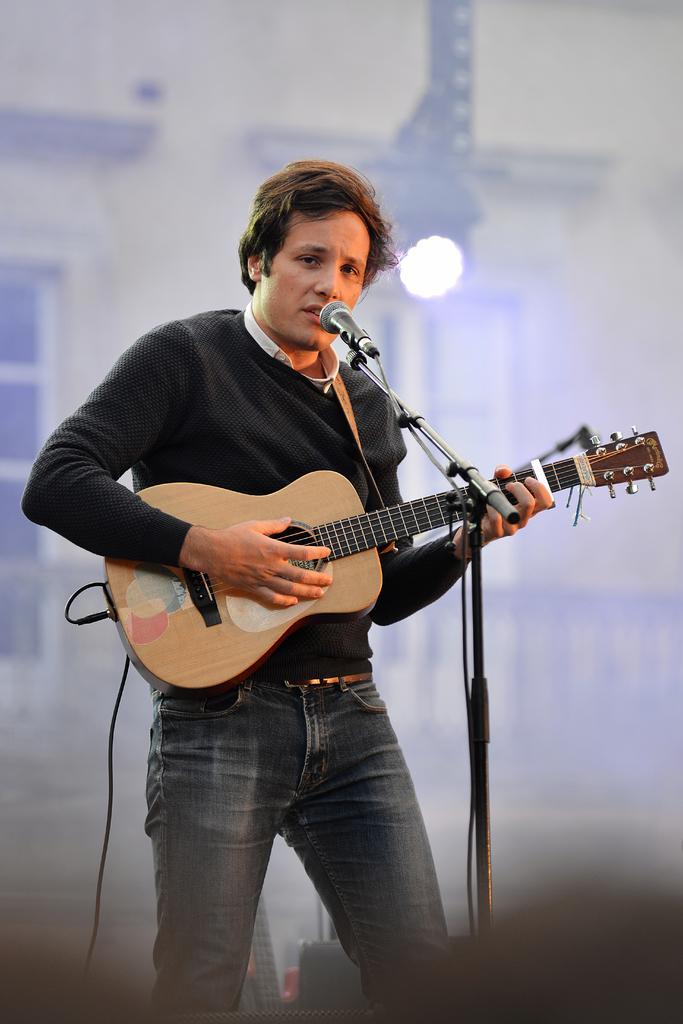Could you give a brief overview of what you see in this image? In the image we can see there is a man who is standing and he is holding a guitar in his hand. In Front of him there is mike with a stand and the background is blurry. 